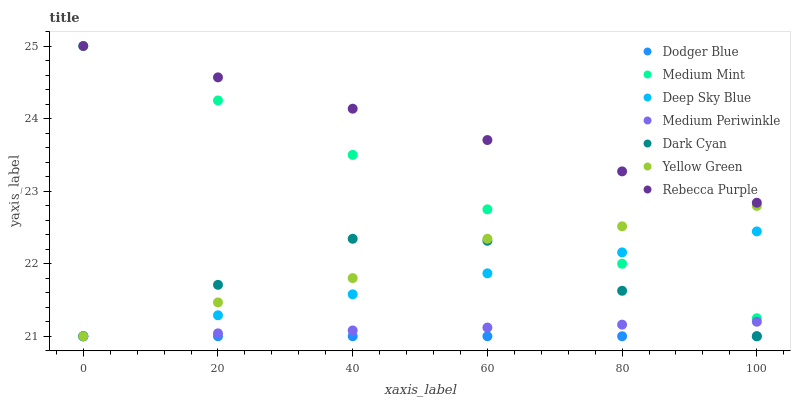Does Dodger Blue have the minimum area under the curve?
Answer yes or no. Yes. Does Rebecca Purple have the maximum area under the curve?
Answer yes or no. Yes. Does Yellow Green have the minimum area under the curve?
Answer yes or no. No. Does Yellow Green have the maximum area under the curve?
Answer yes or no. No. Is Medium Mint the smoothest?
Answer yes or no. Yes. Is Dark Cyan the roughest?
Answer yes or no. Yes. Is Yellow Green the smoothest?
Answer yes or no. No. Is Yellow Green the roughest?
Answer yes or no. No. Does Yellow Green have the lowest value?
Answer yes or no. Yes. Does Rebecca Purple have the lowest value?
Answer yes or no. No. Does Rebecca Purple have the highest value?
Answer yes or no. Yes. Does Yellow Green have the highest value?
Answer yes or no. No. Is Dark Cyan less than Medium Mint?
Answer yes or no. Yes. Is Medium Mint greater than Dark Cyan?
Answer yes or no. Yes. Does Dark Cyan intersect Medium Periwinkle?
Answer yes or no. Yes. Is Dark Cyan less than Medium Periwinkle?
Answer yes or no. No. Is Dark Cyan greater than Medium Periwinkle?
Answer yes or no. No. Does Dark Cyan intersect Medium Mint?
Answer yes or no. No. 